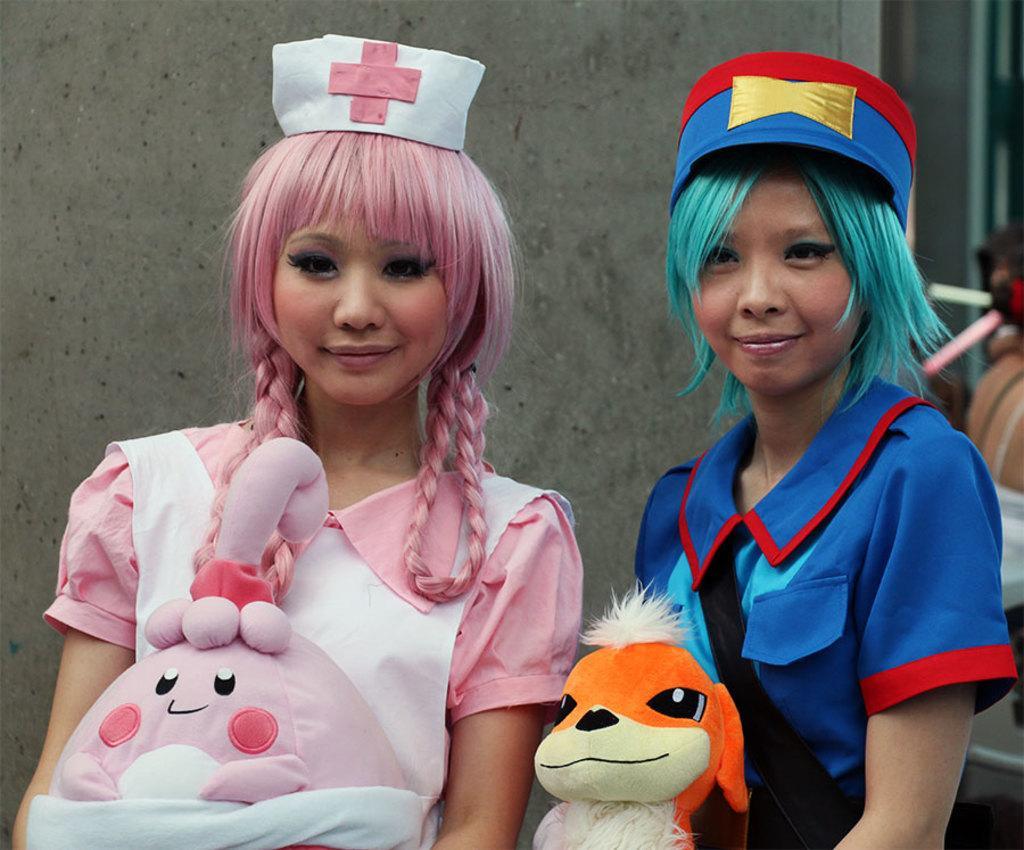Describe this image in one or two sentences. In the foreground of the image there are two ladies wearing caps and holding toys in their hands. In the background of the image there is wall. 